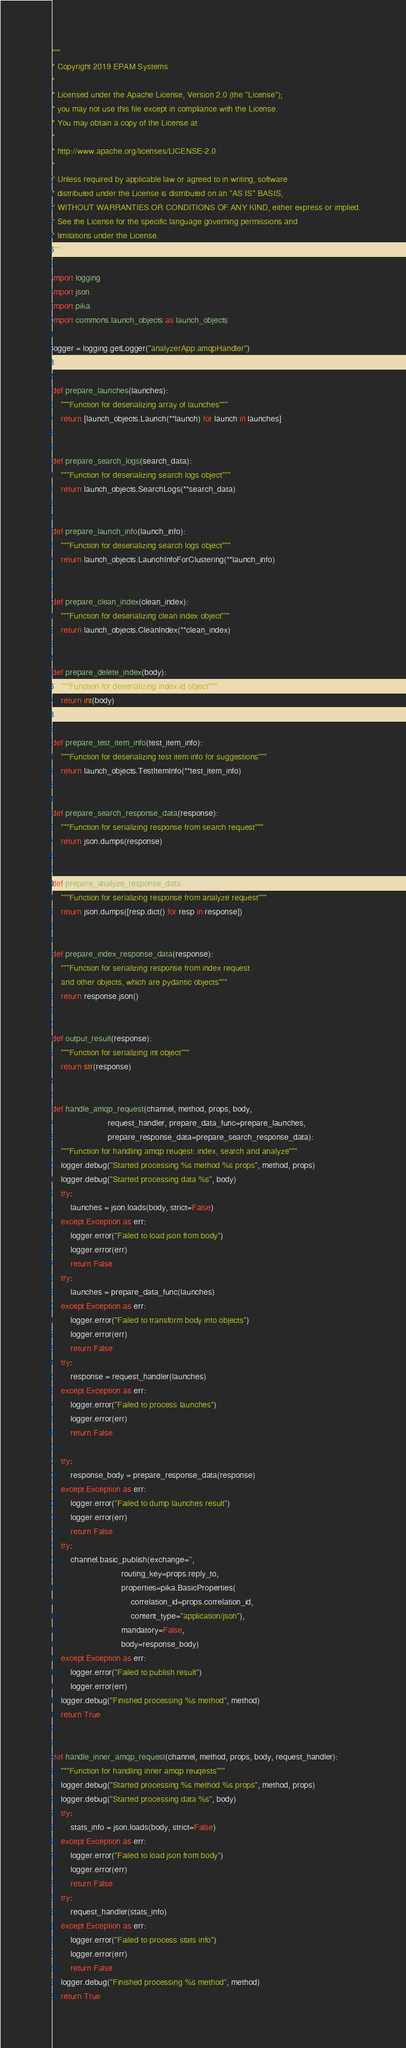Convert code to text. <code><loc_0><loc_0><loc_500><loc_500><_Python_>"""
* Copyright 2019 EPAM Systems
*
* Licensed under the Apache License, Version 2.0 (the "License");
* you may not use this file except in compliance with the License.
* You may obtain a copy of the License at
*
* http://www.apache.org/licenses/LICENSE-2.0
*
* Unless required by applicable law or agreed to in writing, software
* distributed under the License is distributed on an "AS IS" BASIS,
* WITHOUT WARRANTIES OR CONDITIONS OF ANY KIND, either express or implied.
* See the License for the specific language governing permissions and
* limitations under the License.
"""

import logging
import json
import pika
import commons.launch_objects as launch_objects

logger = logging.getLogger("analyzerApp.amqpHandler")


def prepare_launches(launches):
    """Function for deserializing array of launches"""
    return [launch_objects.Launch(**launch) for launch in launches]


def prepare_search_logs(search_data):
    """Function for deserializing search logs object"""
    return launch_objects.SearchLogs(**search_data)


def prepare_launch_info(launch_info):
    """Function for deserializing search logs object"""
    return launch_objects.LaunchInfoForClustering(**launch_info)


def prepare_clean_index(clean_index):
    """Function for deserializing clean index object"""
    return launch_objects.CleanIndex(**clean_index)


def prepare_delete_index(body):
    """Function for deserializing index id object"""
    return int(body)


def prepare_test_item_info(test_item_info):
    """Function for deserializing test item info for suggestions"""
    return launch_objects.TestItemInfo(**test_item_info)


def prepare_search_response_data(response):
    """Function for serializing response from search request"""
    return json.dumps(response)


def prepare_analyze_response_data(response):
    """Function for serializing response from analyze request"""
    return json.dumps([resp.dict() for resp in response])


def prepare_index_response_data(response):
    """Function for serializing response from index request
    and other objects, which are pydantic objects"""
    return response.json()


def output_result(response):
    """Function for serializing int object"""
    return str(response)


def handle_amqp_request(channel, method, props, body,
                        request_handler, prepare_data_func=prepare_launches,
                        prepare_response_data=prepare_search_response_data):
    """Function for handling amqp reuqest: index, search and analyze"""
    logger.debug("Started processing %s method %s props", method, props)
    logger.debug("Started processing data %s", body)
    try:
        launches = json.loads(body, strict=False)
    except Exception as err:
        logger.error("Failed to load json from body")
        logger.error(err)
        return False
    try:
        launches = prepare_data_func(launches)
    except Exception as err:
        logger.error("Failed to transform body into objects")
        logger.error(err)
        return False
    try:
        response = request_handler(launches)
    except Exception as err:
        logger.error("Failed to process launches")
        logger.error(err)
        return False

    try:
        response_body = prepare_response_data(response)
    except Exception as err:
        logger.error("Failed to dump launches result")
        logger.error(err)
        return False
    try:
        channel.basic_publish(exchange='',
                              routing_key=props.reply_to,
                              properties=pika.BasicProperties(
                                  correlation_id=props.correlation_id,
                                  content_type="application/json"),
                              mandatory=False,
                              body=response_body)
    except Exception as err:
        logger.error("Failed to publish result")
        logger.error(err)
    logger.debug("Finished processing %s method", method)
    return True


def handle_inner_amqp_request(channel, method, props, body, request_handler):
    """Function for handling inner amqp reuqests"""
    logger.debug("Started processing %s method %s props", method, props)
    logger.debug("Started processing data %s", body)
    try:
        stats_info = json.loads(body, strict=False)
    except Exception as err:
        logger.error("Failed to load json from body")
        logger.error(err)
        return False
    try:
        request_handler(stats_info)
    except Exception as err:
        logger.error("Failed to process stats info")
        logger.error(err)
        return False
    logger.debug("Finished processing %s method", method)
    return True
</code> 